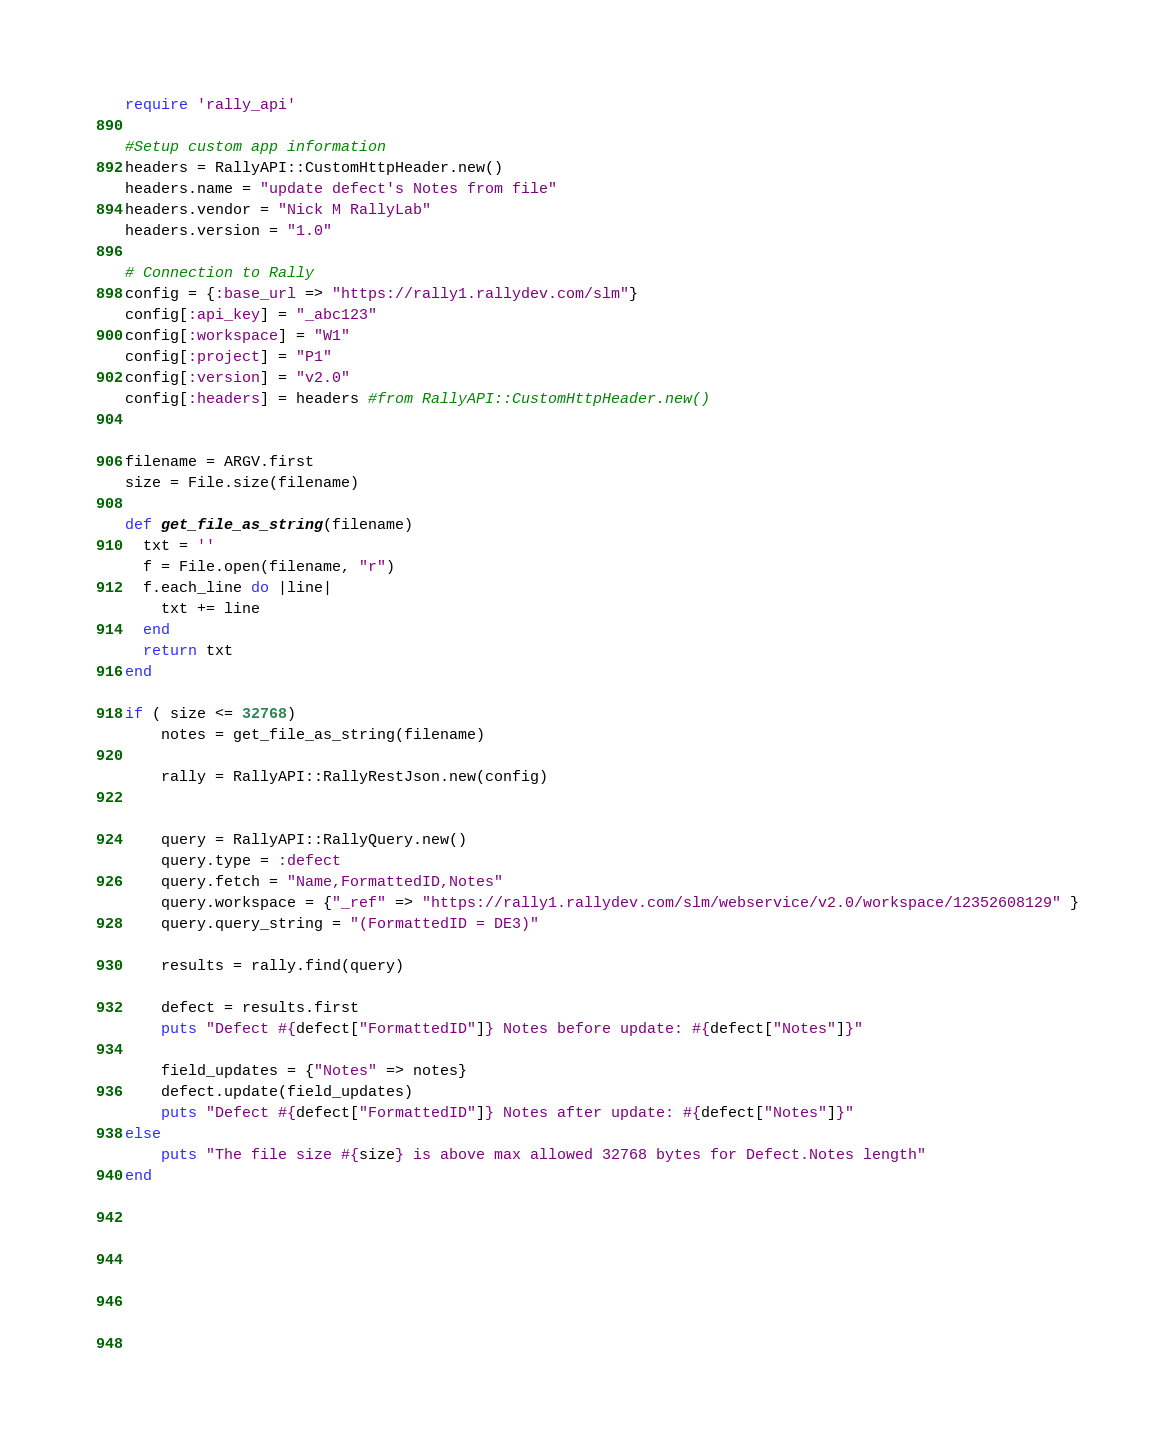Convert code to text. <code><loc_0><loc_0><loc_500><loc_500><_Ruby_>require 'rally_api'

#Setup custom app information
headers = RallyAPI::CustomHttpHeader.new()
headers.name = "update defect's Notes from file"
headers.vendor = "Nick M RallyLab"
headers.version = "1.0"

# Connection to Rally
config = {:base_url => "https://rally1.rallydev.com/slm"}
config[:api_key] = "_abc123"
config[:workspace] = "W1"
config[:project] = "P1"
config[:version] = "v2.0"
config[:headers] = headers #from RallyAPI::CustomHttpHeader.new()


filename = ARGV.first
size = File.size(filename)

def get_file_as_string(filename)
  txt = ''
  f = File.open(filename, "r") 
  f.each_line do |line|
    txt += line
  end
  return txt
end

if ( size <= 32768)
	notes = get_file_as_string(filename)

	rally = RallyAPI::RallyRestJson.new(config)


	query = RallyAPI::RallyQuery.new()
	query.type = :defect
	query.fetch = "Name,FormattedID,Notes"
	query.workspace = {"_ref" => "https://rally1.rallydev.com/slm/webservice/v2.0/workspace/12352608129" }
	query.query_string = "(FormattedID = DE3)"

	results = rally.find(query)

	defect = results.first
	puts "Defect #{defect["FormattedID"]} Notes before update: #{defect["Notes"]}"

	field_updates = {"Notes" => notes}
	defect.update(field_updates)
	puts "Defect #{defect["FormattedID"]} Notes after update: #{defect["Notes"]}"
else
	puts "The file size #{size} is above max allowed 32768 bytes for Defect.Notes length"
end





	

	


</code> 